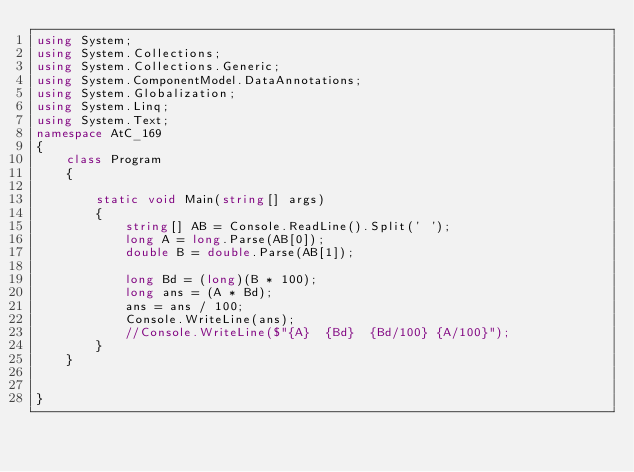Convert code to text. <code><loc_0><loc_0><loc_500><loc_500><_C#_>using System;
using System.Collections;
using System.Collections.Generic;
using System.ComponentModel.DataAnnotations;
using System.Globalization;
using System.Linq;
using System.Text;
namespace AtC_169
{
    class Program
    {

        static void Main(string[] args)
        {
            string[] AB = Console.ReadLine().Split(' ');
            long A = long.Parse(AB[0]);
            double B = double.Parse(AB[1]);

            long Bd = (long)(B * 100);
            long ans = (A * Bd);
            ans = ans / 100;
            Console.WriteLine(ans);
            //Console.WriteLine($"{A}  {Bd}  {Bd/100} {A/100}");
        }
    }

    
}
</code> 